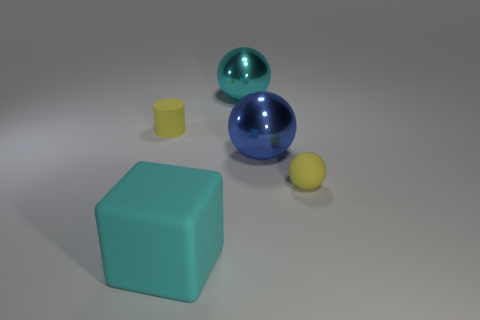Why is there a difference in size among these objects, and does it suggest anything about their purpose or context? The difference in size among the objects might suggest that they serve different purposes or are meant to represent varying scales. A larger object could be part of a display or educational model, while smaller ones might be toy components or part of a collection. The context isn't clear from just the image, but the variety in size often adds visual interest to a composition or can be used to teach proportion and perspective. 